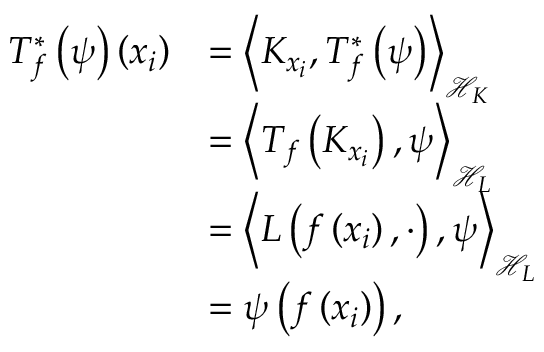<formula> <loc_0><loc_0><loc_500><loc_500>\begin{array} { r l } { T _ { f } ^ { * } \left ( \psi \right ) \left ( x _ { i } \right ) } & { = \left \langle K _ { x _ { i } } , T _ { f } ^ { * } \left ( \psi \right ) \right \rangle _ { \ m a t h s c r { H } _ { K } } } \\ & { = \left \langle T _ { f } \left ( K _ { x _ { i } } \right ) , \psi \right \rangle _ { \ m a t h s c r { H } _ { L } } } \\ & { = \left \langle L \left ( f \left ( x _ { i } \right ) , \cdot \right ) , \psi \right \rangle _ { \ m a t h s c r { H } _ { L } } } \\ & { = \psi \left ( f \left ( x _ { i } \right ) \right ) , } \end{array}</formula> 